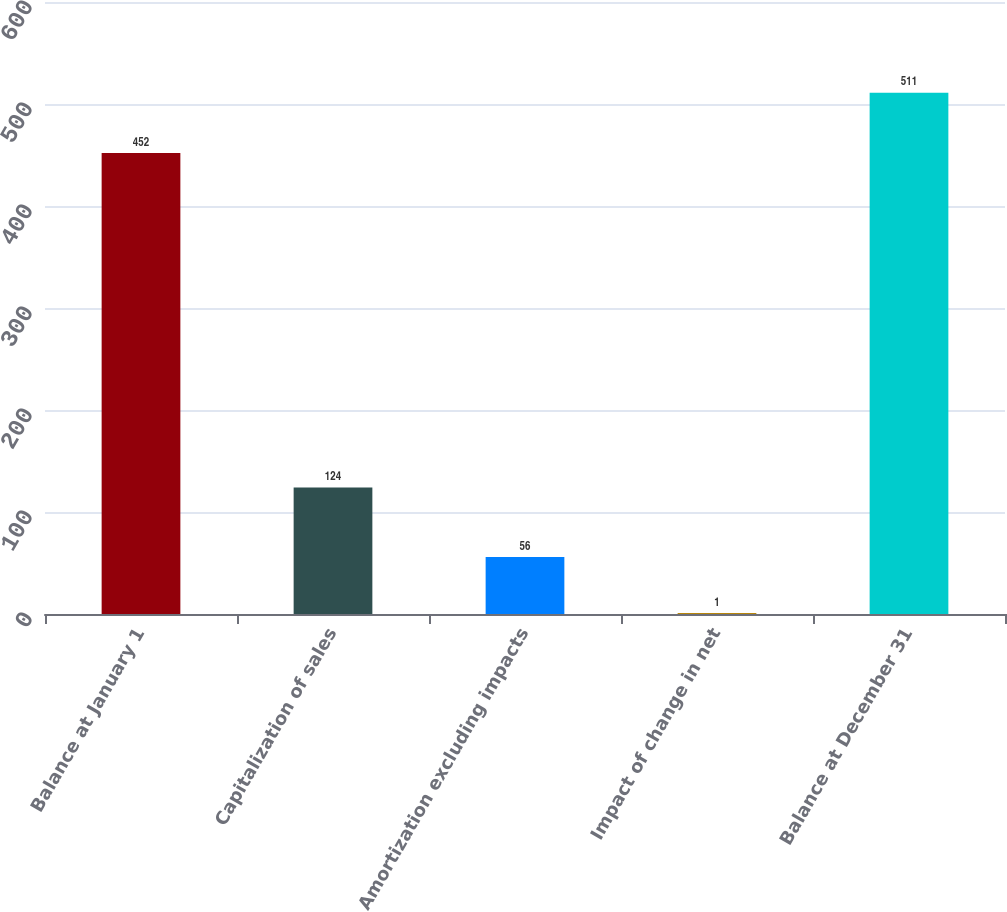Convert chart to OTSL. <chart><loc_0><loc_0><loc_500><loc_500><bar_chart><fcel>Balance at January 1<fcel>Capitalization of sales<fcel>Amortization excluding impacts<fcel>Impact of change in net<fcel>Balance at December 31<nl><fcel>452<fcel>124<fcel>56<fcel>1<fcel>511<nl></chart> 